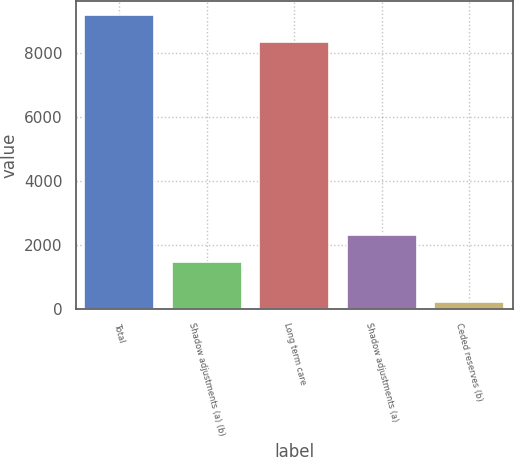Convert chart. <chart><loc_0><loc_0><loc_500><loc_500><bar_chart><fcel>Total<fcel>Shadow adjustments (a) (b)<fcel>Long term care<fcel>Shadow adjustments (a)<fcel>Ceded reserves (b)<nl><fcel>9179.7<fcel>1459<fcel>8335<fcel>2303.7<fcel>207<nl></chart> 